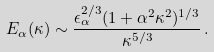Convert formula to latex. <formula><loc_0><loc_0><loc_500><loc_500>E _ { \alpha } ( \kappa ) \sim \frac { \epsilon ^ { 2 / 3 } _ { \alpha } ( 1 + \alpha ^ { 2 } \kappa ^ { 2 } ) ^ { 1 / 3 } } { \kappa ^ { 5 / 3 } } \, .</formula> 